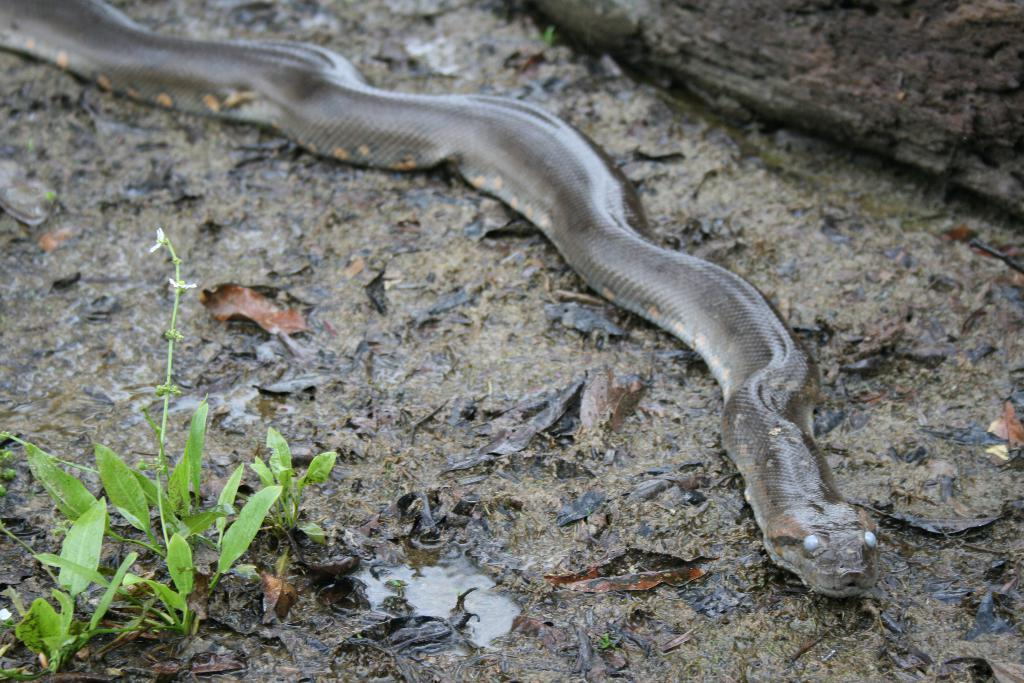What animal is present in the image? There is a snake in the image. Where is the snake located? The snake is on a rock. What type of vegetation can be seen in the image? There is grass visible in the image. What type of cast can be seen on the snake's body in the image? There is no cast present on the snake's body in the image. What type of board is the snake using to balance on the rock? There is no board present in the image; the snake is simply on the rock. 